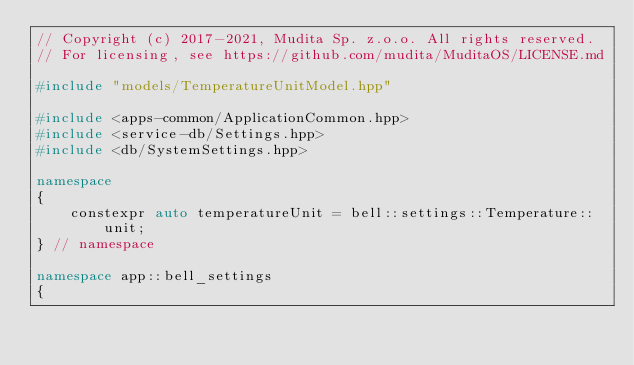Convert code to text. <code><loc_0><loc_0><loc_500><loc_500><_C++_>// Copyright (c) 2017-2021, Mudita Sp. z.o.o. All rights reserved.
// For licensing, see https://github.com/mudita/MuditaOS/LICENSE.md

#include "models/TemperatureUnitModel.hpp"

#include <apps-common/ApplicationCommon.hpp>
#include <service-db/Settings.hpp>
#include <db/SystemSettings.hpp>

namespace
{
    constexpr auto temperatureUnit = bell::settings::Temperature::unit;
} // namespace

namespace app::bell_settings
{</code> 